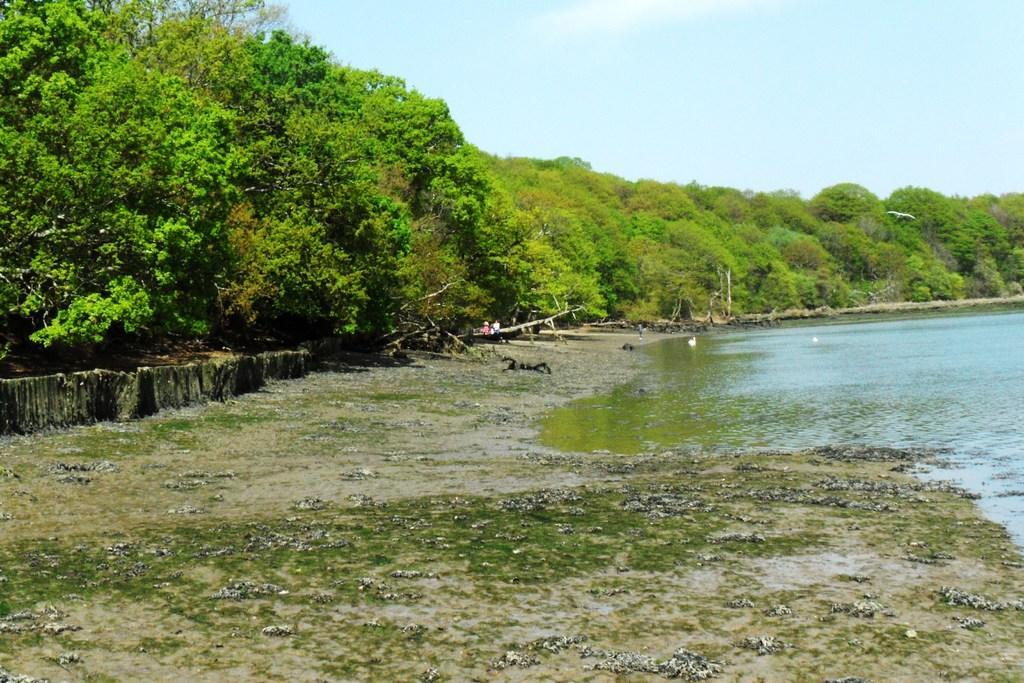In one or two sentences, can you explain what this image depicts? In the mage there is a water surface and around that there are plenty of trees. 